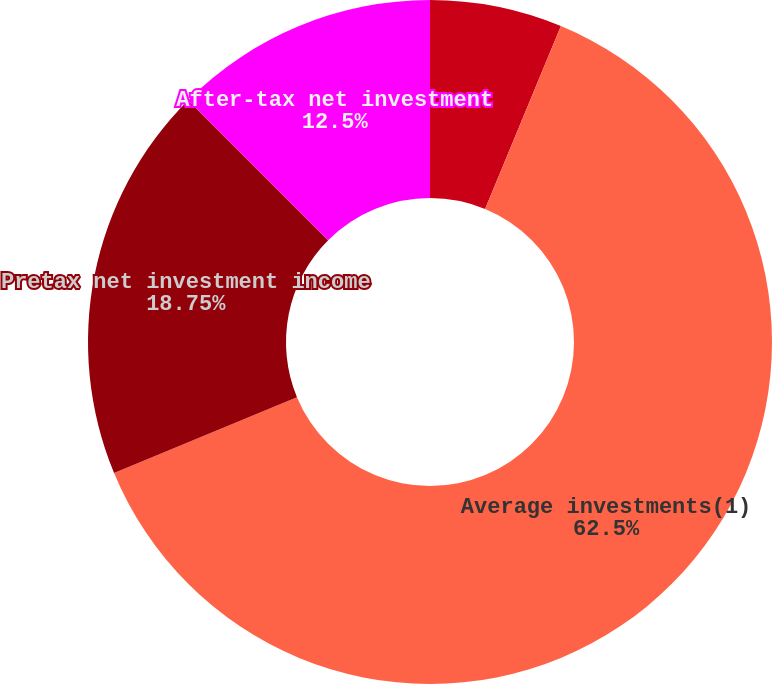Convert chart to OTSL. <chart><loc_0><loc_0><loc_500><loc_500><pie_chart><fcel>(for the year ended December<fcel>Average investments(1)<fcel>Pretax net investment income<fcel>After-tax net investment<fcel>Average pretax yield(2)<nl><fcel>6.25%<fcel>62.49%<fcel>18.75%<fcel>12.5%<fcel>0.0%<nl></chart> 